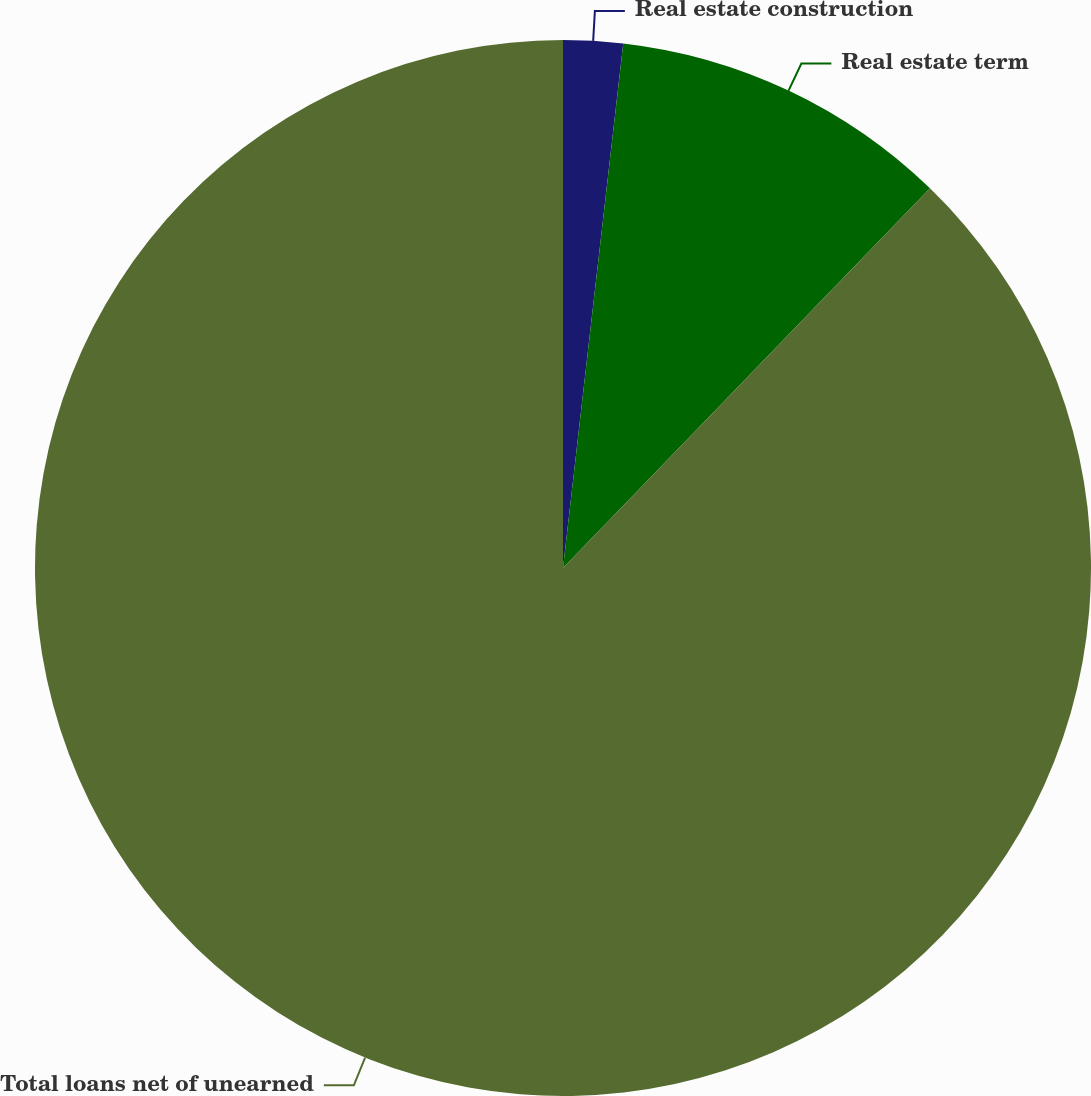Convert chart to OTSL. <chart><loc_0><loc_0><loc_500><loc_500><pie_chart><fcel>Real estate construction<fcel>Real estate term<fcel>Total loans net of unearned<nl><fcel>1.82%<fcel>10.41%<fcel>87.77%<nl></chart> 